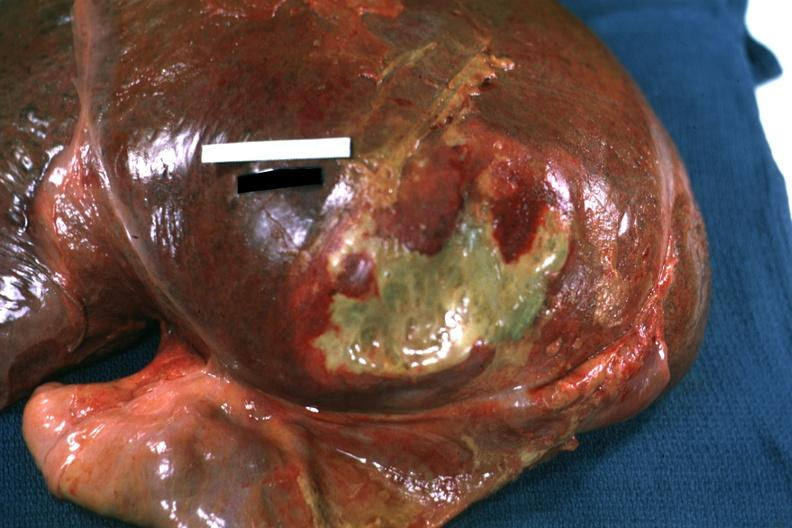what reflected to show flat mass of yellow green pus quite good example?
Answer the question using a single word or phrase. Right leaf diaphragm 